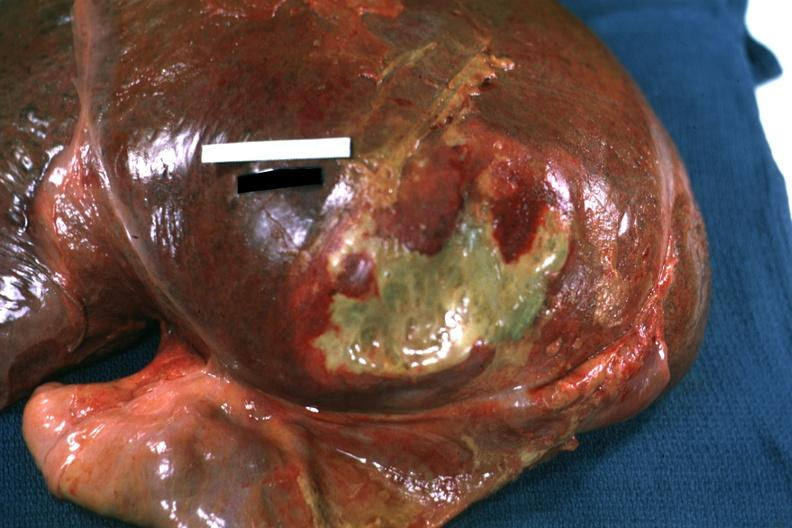what reflected to show flat mass of yellow green pus quite good example?
Answer the question using a single word or phrase. Right leaf diaphragm 